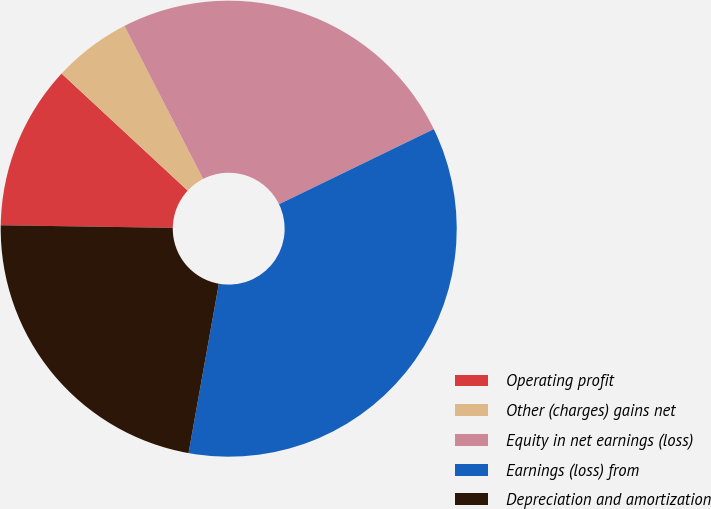Convert chart. <chart><loc_0><loc_0><loc_500><loc_500><pie_chart><fcel>Operating profit<fcel>Other (charges) gains net<fcel>Equity in net earnings (loss)<fcel>Earnings (loss) from<fcel>Depreciation and amortization<nl><fcel>11.67%<fcel>5.53%<fcel>25.37%<fcel>35.01%<fcel>22.42%<nl></chart> 